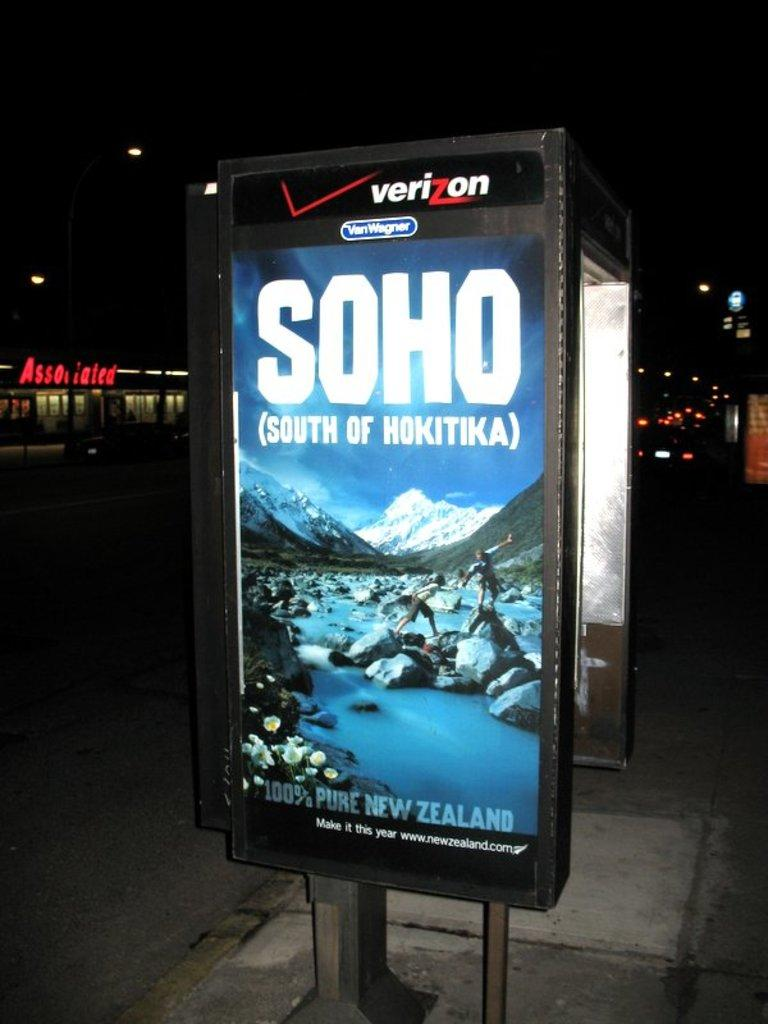Provide a one-sentence caption for the provided image. a poster on the sidewalk that says 'soho south of hokitika' on it. 